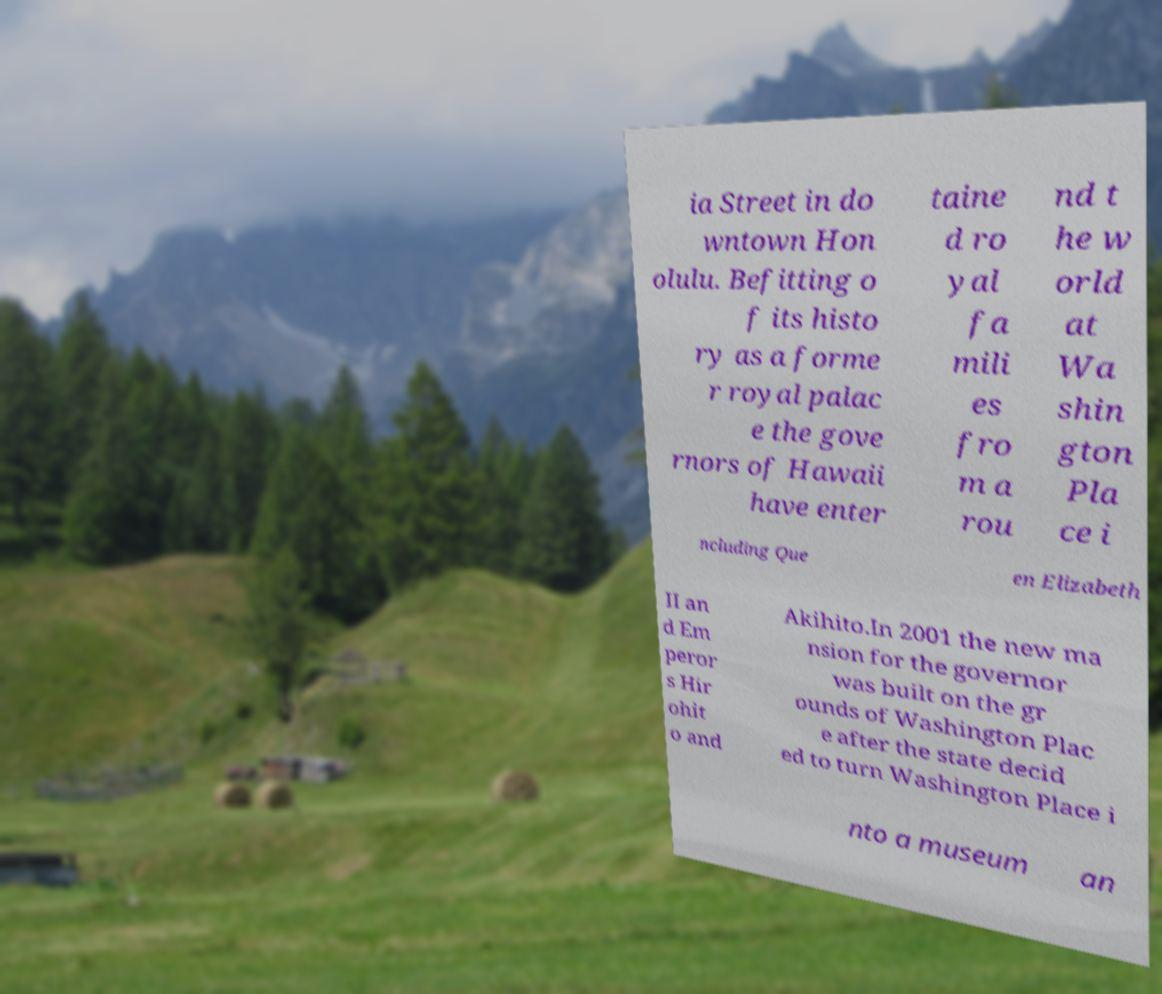Can you read and provide the text displayed in the image?This photo seems to have some interesting text. Can you extract and type it out for me? ia Street in do wntown Hon olulu. Befitting o f its histo ry as a forme r royal palac e the gove rnors of Hawaii have enter taine d ro yal fa mili es fro m a rou nd t he w orld at Wa shin gton Pla ce i ncluding Que en Elizabeth II an d Em peror s Hir ohit o and Akihito.In 2001 the new ma nsion for the governor was built on the gr ounds of Washington Plac e after the state decid ed to turn Washington Place i nto a museum an 